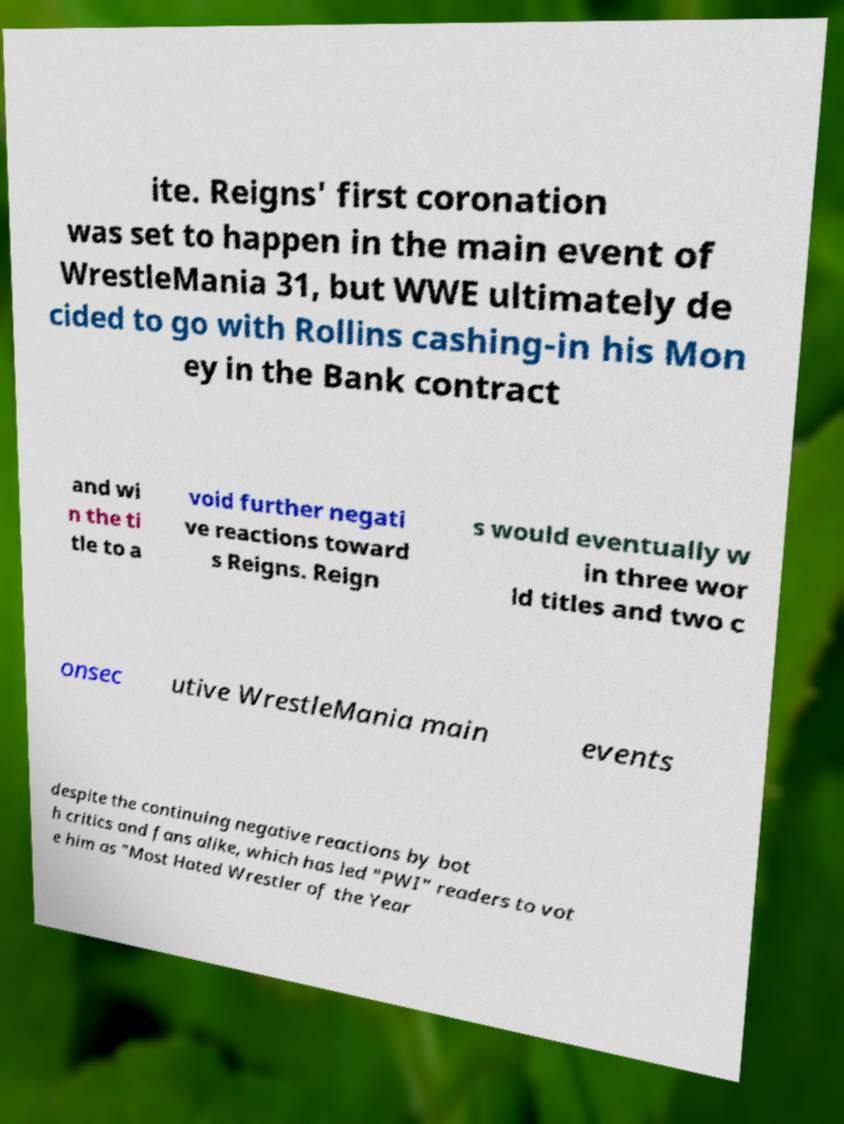Can you read and provide the text displayed in the image?This photo seems to have some interesting text. Can you extract and type it out for me? ite. Reigns' first coronation was set to happen in the main event of WrestleMania 31, but WWE ultimately de cided to go with Rollins cashing-in his Mon ey in the Bank contract and wi n the ti tle to a void further negati ve reactions toward s Reigns. Reign s would eventually w in three wor ld titles and two c onsec utive WrestleMania main events despite the continuing negative reactions by bot h critics and fans alike, which has led "PWI" readers to vot e him as "Most Hated Wrestler of the Year 